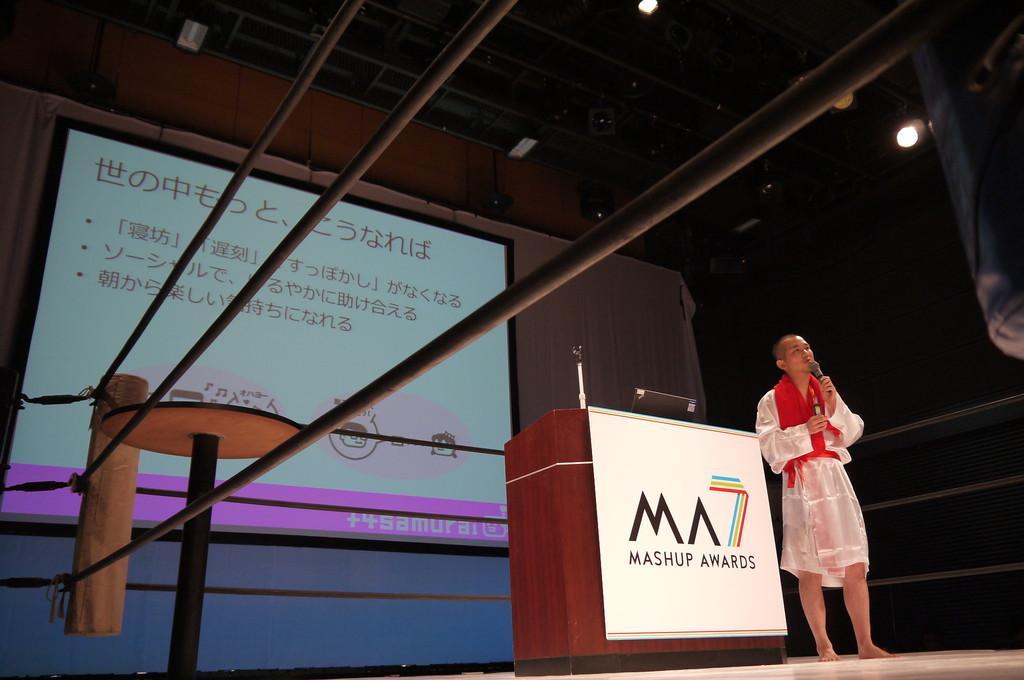Can you describe this image briefly? In this image we can see a person holding a mic and standing on the stage, there is a podium, on the podium, we can see a mic, laptop and a board with some text, also we can see a screen and a stand, at the top we can see some lights and there are some rods. 